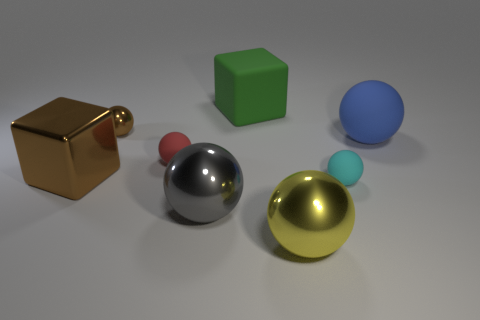How does the lighting in the image affect the appearance of the objects, and can you infer the light source's position? The lighting casts soft shadows to the right side of the objects, indicating the light source is to the left. The shadows also show variations in opacity, which highlights the smoothness of the surfaces and gives the scene a three-dimensional quality. 